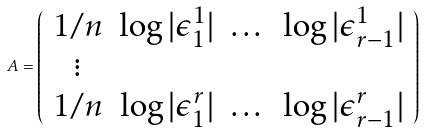Convert formula to latex. <formula><loc_0><loc_0><loc_500><loc_500>A = \left ( \begin{array} { c c c c } 1 / n & \log | \epsilon _ { 1 } ^ { 1 } | & \dots & \log | \epsilon _ { r - 1 } ^ { 1 } | \\ \vdots & & & \\ 1 / n & \log | \epsilon _ { 1 } ^ { r } | & \dots & \log | \epsilon _ { r - 1 } ^ { r } | \end{array} \right )</formula> 